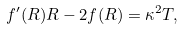<formula> <loc_0><loc_0><loc_500><loc_500>f ^ { \prime } ( R ) R - 2 f ( R ) = \kappa ^ { 2 } T ,</formula> 